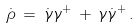<formula> <loc_0><loc_0><loc_500><loc_500>\dot { \rho } \, = \, \dot { \gamma } \gamma ^ { + } \, + \, \gamma \dot { \gamma } ^ { + } \, .</formula> 